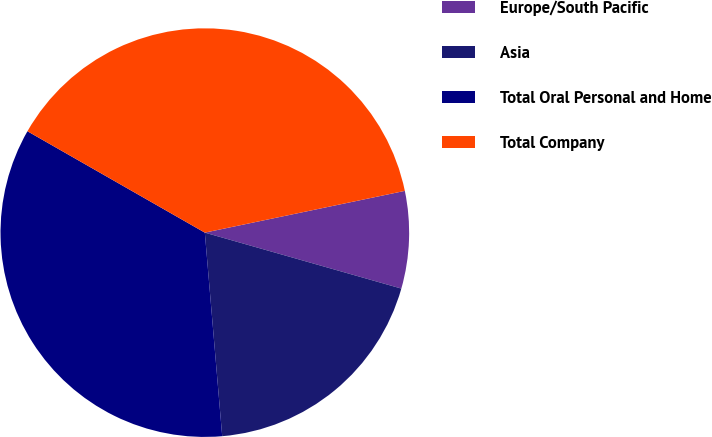Convert chart. <chart><loc_0><loc_0><loc_500><loc_500><pie_chart><fcel>Europe/South Pacific<fcel>Asia<fcel>Total Oral Personal and Home<fcel>Total Company<nl><fcel>7.69%<fcel>19.23%<fcel>34.62%<fcel>38.46%<nl></chart> 